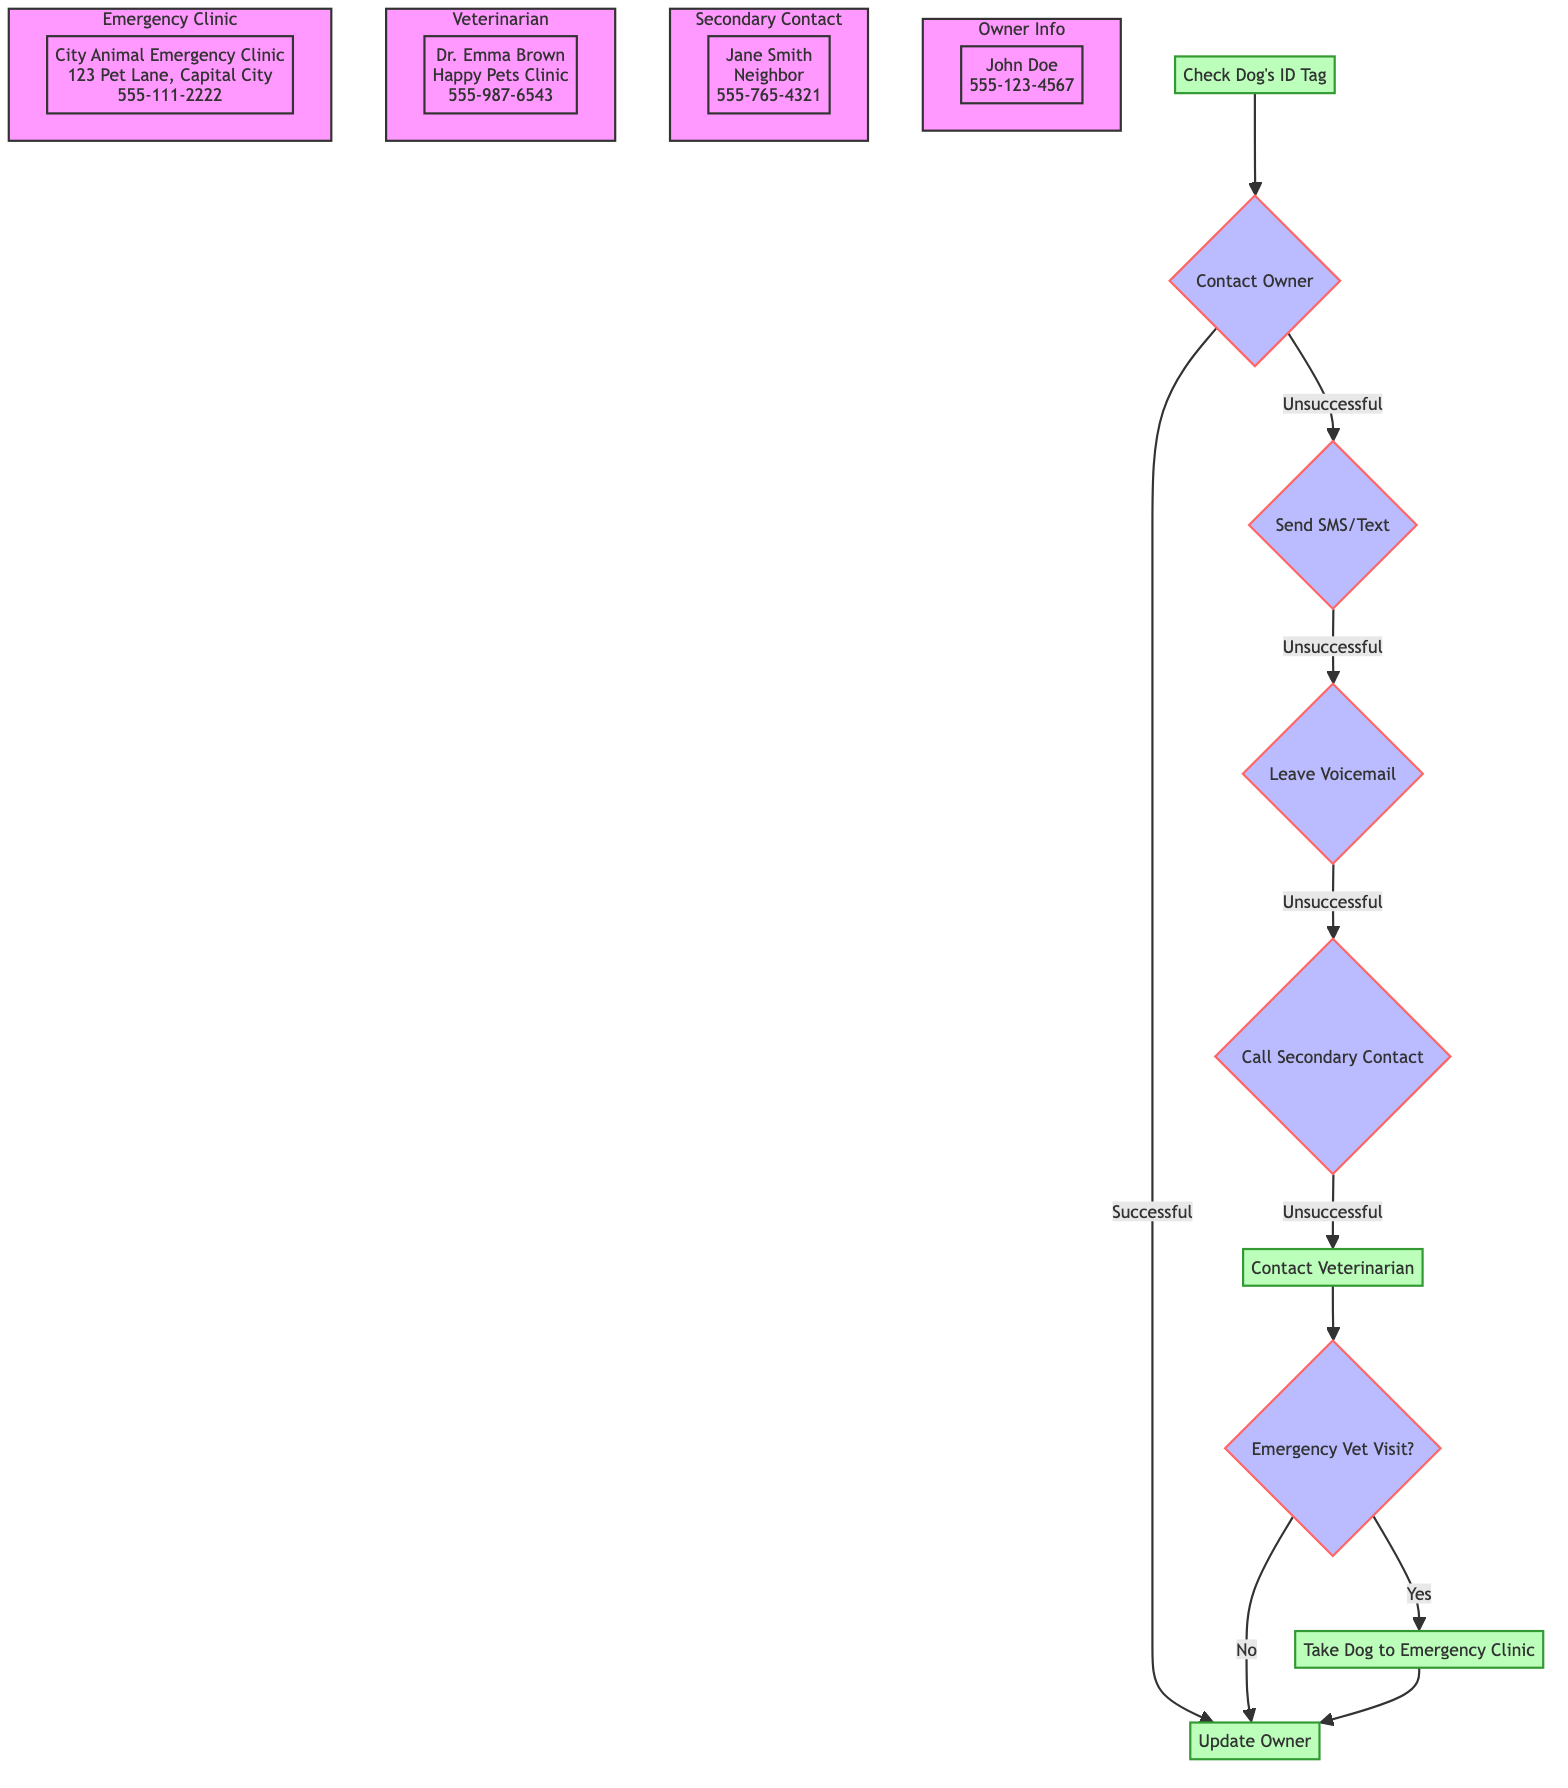What is the first action taken in the emergency protocol? The first action taken is to check the dog's ID tag, as indicated by the first node in the diagram.
Answer: Check Dog's ID Tag Who is the primary owner to be contacted? The diagram specifies that the primary owner to be contacted is John Doe, as shown in the connection in the flowchart.
Answer: John Doe How many alternative actions are there if contacting the owner is unsuccessful? The flowchart indicates that there are three alternative actions outlined if the owner cannot be contacted, which are sending an SMS, leaving a voicemail, and calling a secondary contact.
Answer: Three What should the dog walker do if the owner is unreachable and the dog is in need of veterinary assistance? According to the flowchart, the dog walker should contact the veterinarian, as indicated in the sequence of actions following the unsuccessful attempt to contact the owner.
Answer: Contact Veterinarian If the veterinarian is contacted, what is the veterinarian's name? In the flowchart, the veterinarian's name is specified as Dr. Emma Brown, who is listed with her contact information.
Answer: Dr. Emma Brown What happens if the decision to take the dog to the emergency vet is made? If the decision for an emergency vet visit is confirmed, the flowchart indicates that the action will be to take the dog to the nearest emergency veterinary clinic.
Answer: Take Dog to Emergency Clinic What is the secondary contact's phone number? The diagram provides the phone number of the secondary contact, Jane Smith, as 555-765-4321, which can be found within the relevant subgraph.
Answer: 555-765-4321 What is the contact number for the emergency veterinary clinic? The emergency veterinary clinic's contact number is stated in the diagram as 555-111-2222, which is part of the information provided for the clinic.
Answer: 555-111-2222 What should be done to update the owner in case of an emergency? The flowchart specifies that once the owner is reachable, the dog walker needs to inform the owner about the situation and the actions taken.
Answer: Update Owner 